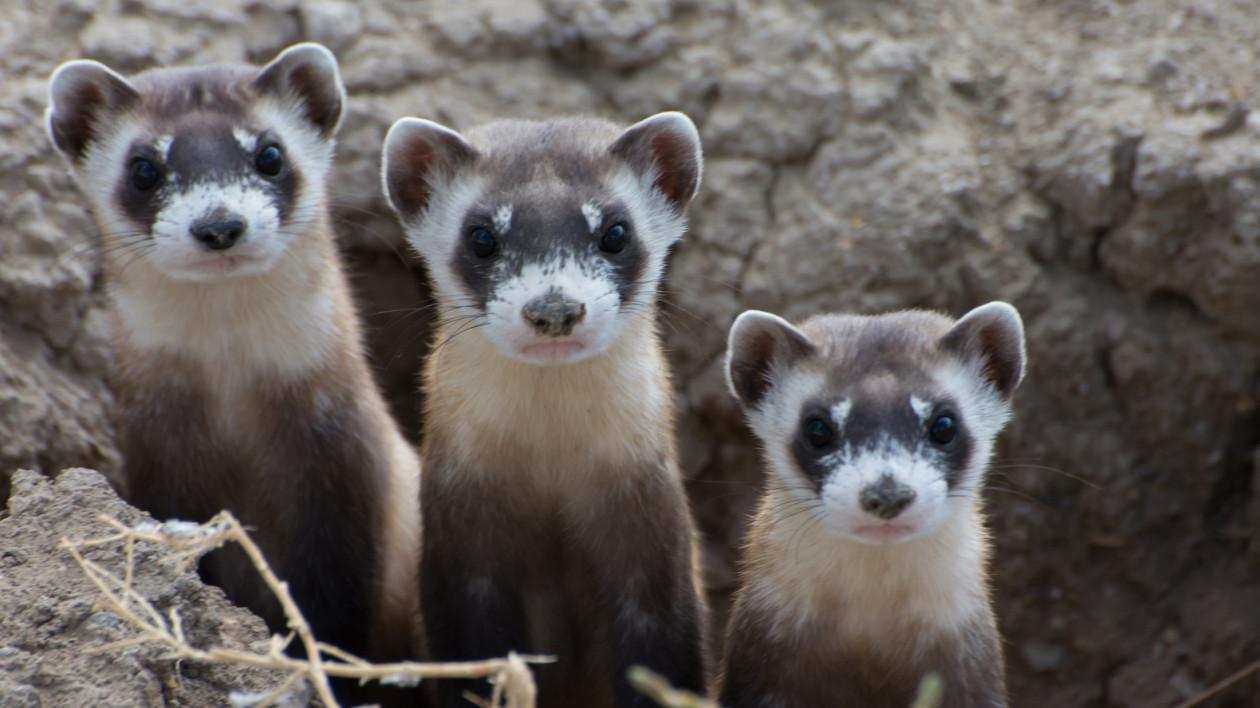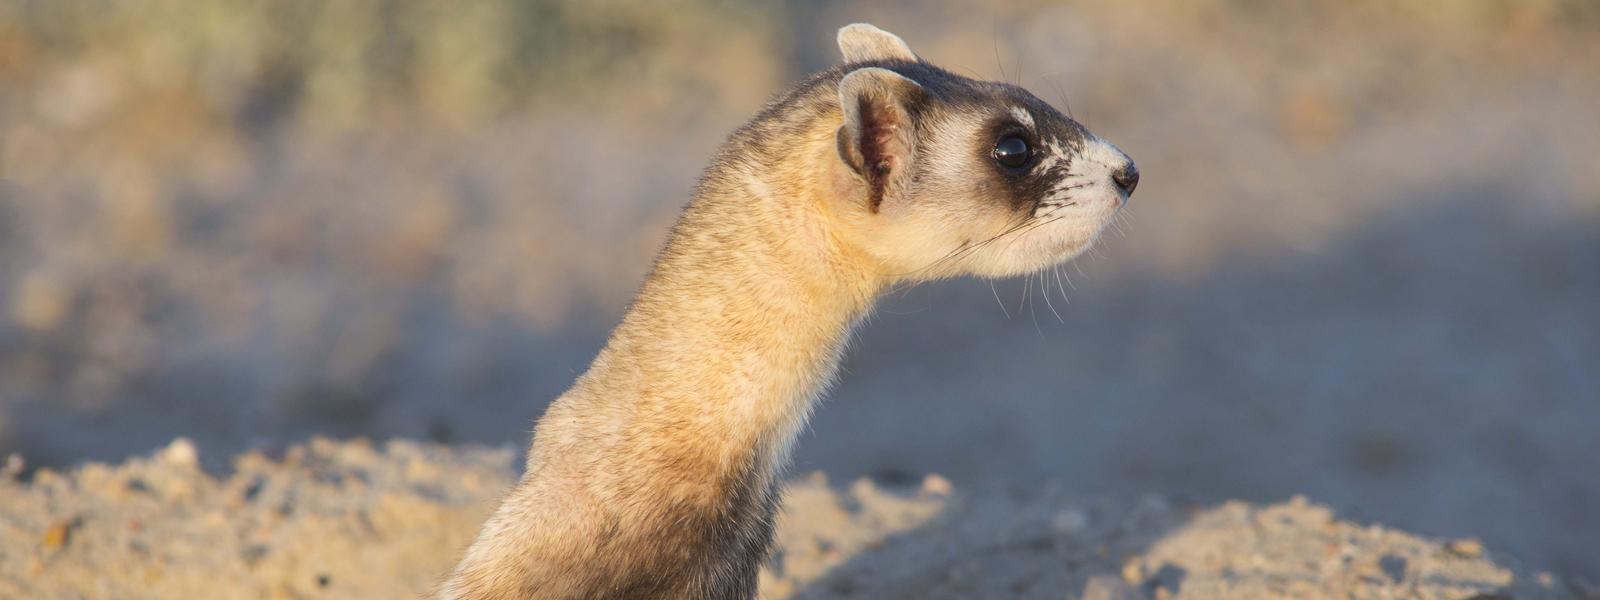The first image is the image on the left, the second image is the image on the right. Considering the images on both sides, is "At least one of the images shows a ferret with it's mouth wide open." valid? Answer yes or no. No. The first image is the image on the left, the second image is the image on the right. Considering the images on both sides, is "ferrets mouth is open wide" valid? Answer yes or no. No. The first image is the image on the left, the second image is the image on the right. Evaluate the accuracy of this statement regarding the images: "In one of the photos, the animal has its mouth wide open.". Is it true? Answer yes or no. No. 